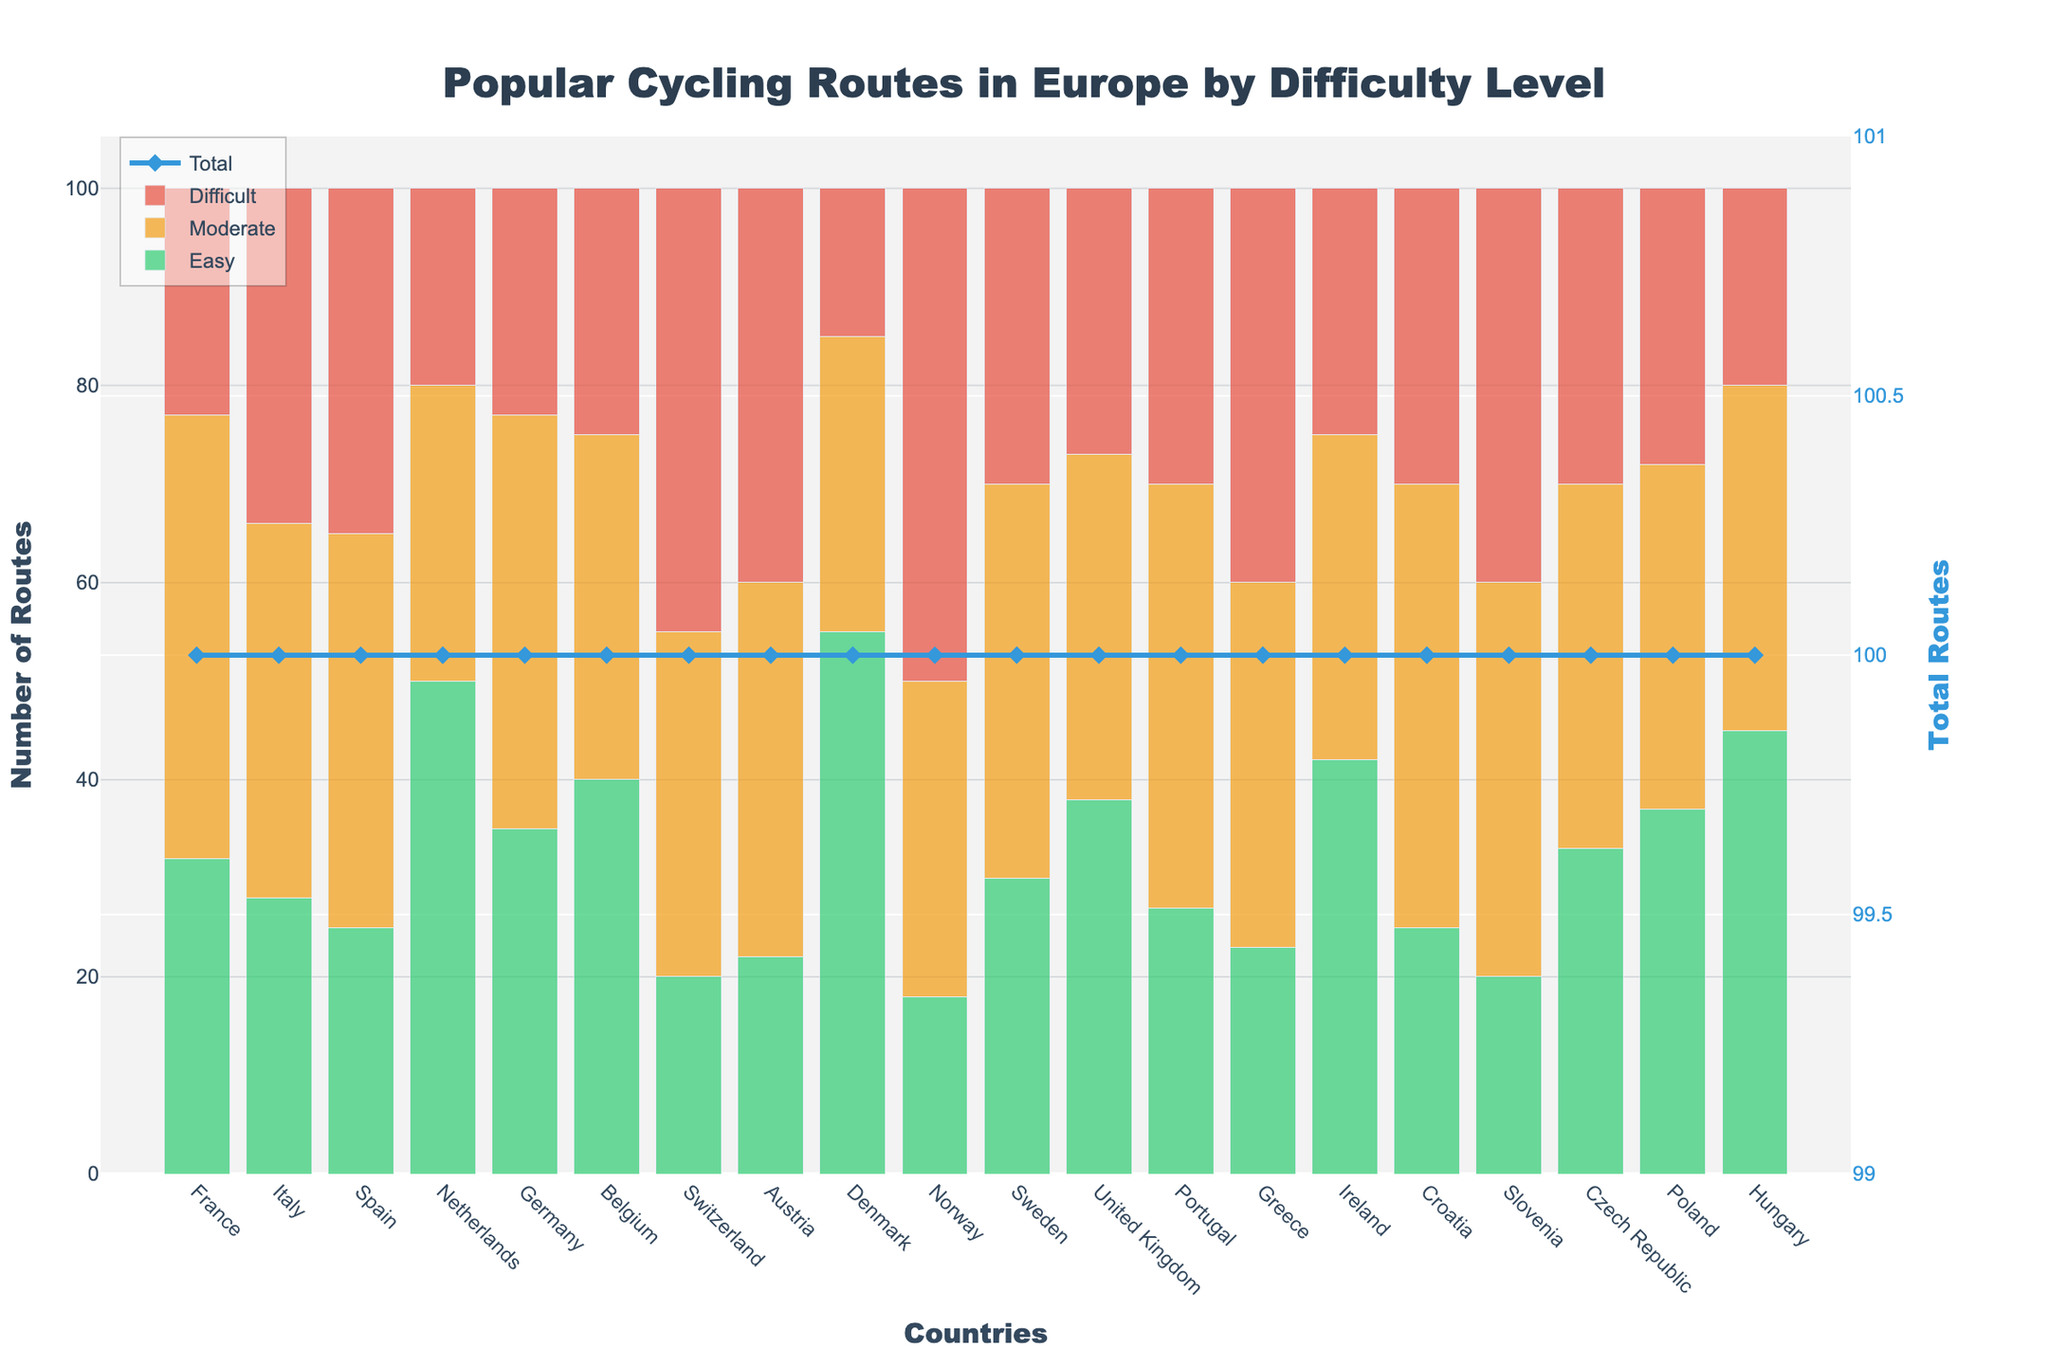what country has the highest number of easy cycling routes? Look at the bars representing easy routes. The green bar for Denmark is the highest.
Answer: Denmark comparing france and spain, which country has more difficult routes? France has 23 difficult routes (red bar) while Spain has 35. Therefore, Spain has more difficult routes.
Answer: Spain what is the combined total number of moderate and difficult cycling routes in Switzerland? Add the moderate (35) and difficult (45) routes in Switzerland. 35 + 45 = 80.
Answer: 80 out of the netherlands, germany, and belgium, which country has the least difficult routes? The Netherlands has 20, Germany has 23, and Belgium has 25 difficult routes. The Netherlands has the least.
Answer: Netherlands what is the total number of routes in austria? Sum the easy (22), moderate (38), and difficult (40) routes in Austria. 22 + 38 + 40 = 100.
Answer: 100 which country has the most even distribution across easy, moderate, and difficult cycling routes? Look for bars of similar height across all difficulty levels. The United Kingdom’s bars are relatively even.
Answer: United Kingdom how many more easy routes does denmark have compared to italy? Denmark has 55 easy routes and Italy has 28. Subtract to find the difference: 55 - 28 = 27.
Answer: 27 is there any country where difficult routes outnumber easy and moderate routes combined? Check if the red bar is taller than the sum of green and orange bars for any country. In Norway, there are 50 difficult routes and 18 (easy) + 32 (moderate) = 50, which is not more. No country meets this criterion.
Answer: No which two countries have the highest total route count? Look for the highest points in the 'Total' line. Denmark and Netherlands have the highest totals.
Answer: Denmark and Netherlands 